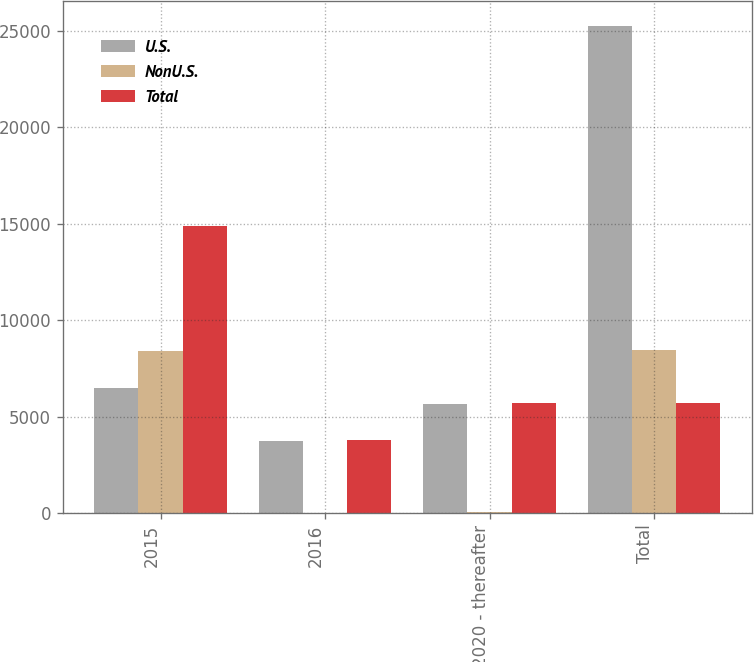Convert chart to OTSL. <chart><loc_0><loc_0><loc_500><loc_500><stacked_bar_chart><ecel><fcel>2015<fcel>2016<fcel>2020 - thereafter<fcel>Total<nl><fcel>U.S.<fcel>6478<fcel>3755<fcel>5661<fcel>25269<nl><fcel>NonU.S.<fcel>8395<fcel>8<fcel>43<fcel>8446<nl><fcel>Total<fcel>14873<fcel>3763<fcel>5704<fcel>5704<nl></chart> 